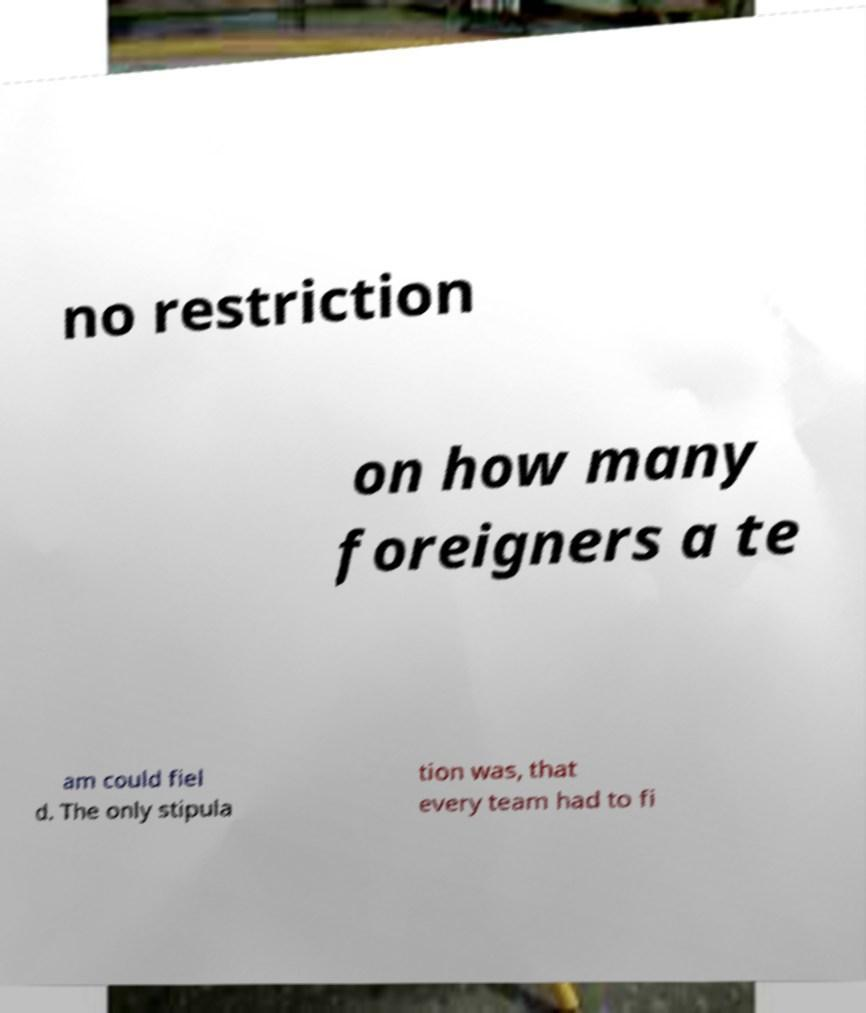There's text embedded in this image that I need extracted. Can you transcribe it verbatim? no restriction on how many foreigners a te am could fiel d. The only stipula tion was, that every team had to fi 